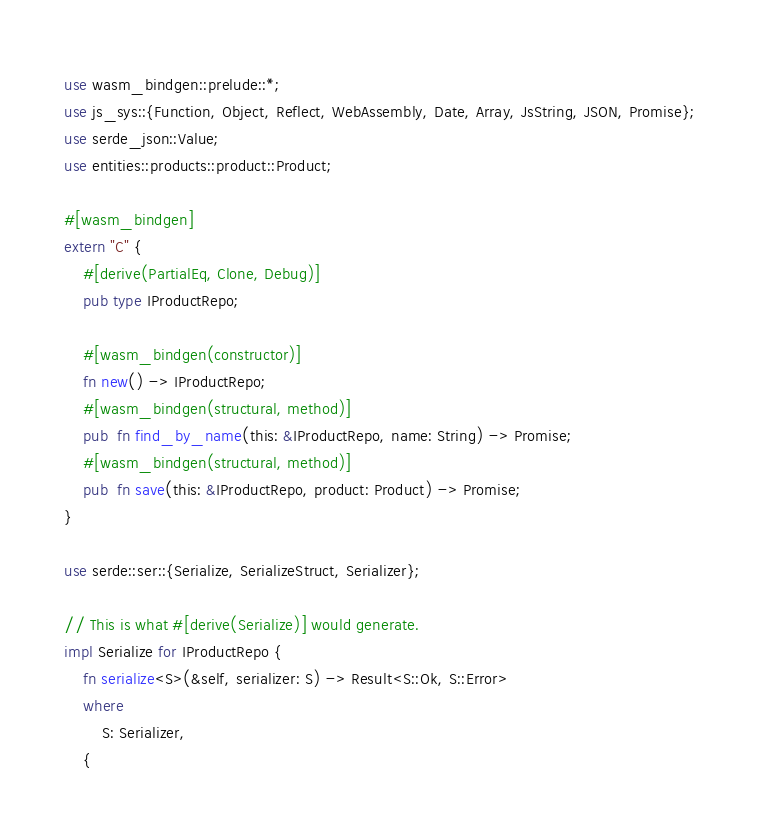<code> <loc_0><loc_0><loc_500><loc_500><_Rust_>use wasm_bindgen::prelude::*;
use js_sys::{Function, Object, Reflect, WebAssembly, Date, Array, JsString, JSON, Promise};
use serde_json::Value;
use entities::products::product::Product;

#[wasm_bindgen]
extern "C" {
    #[derive(PartialEq, Clone, Debug)]
    pub type IProductRepo;

    #[wasm_bindgen(constructor)]
    fn new() -> IProductRepo;
    #[wasm_bindgen(structural, method)]
    pub  fn find_by_name(this: &IProductRepo, name: String) -> Promise;
    #[wasm_bindgen(structural, method)]
    pub  fn save(this: &IProductRepo, product: Product) -> Promise;
}

use serde::ser::{Serialize, SerializeStruct, Serializer};

// This is what #[derive(Serialize)] would generate.
impl Serialize for IProductRepo {
    fn serialize<S>(&self, serializer: S) -> Result<S::Ok, S::Error>
    where
        S: Serializer,
    {</code> 